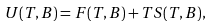Convert formula to latex. <formula><loc_0><loc_0><loc_500><loc_500>U ( T , B ) = F ( T , B ) + T S ( T , B ) ,</formula> 